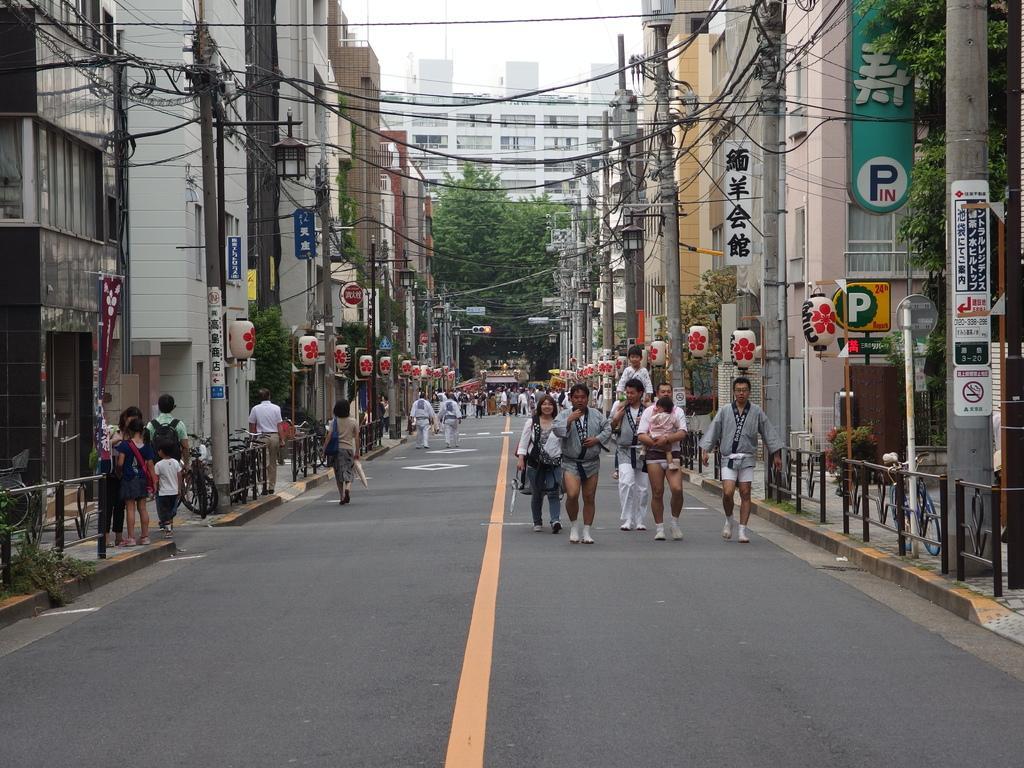In one or two sentences, can you explain what this image depicts? Here in this picture we can see number of people walking on the road over there and beside them on either side we can see buildings present and we can also see banners and hoardings on the buildings and we can also see electric poles, light posts present and we can see plants and trees present and we can see the sky is clear. 